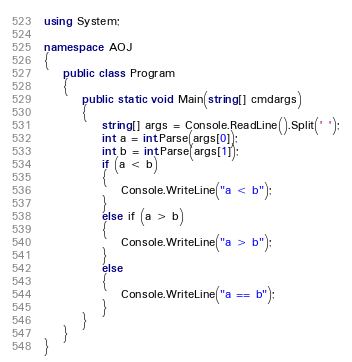Convert code to text. <code><loc_0><loc_0><loc_500><loc_500><_C#_>using System;

namespace AOJ
{
    public class Program
    {
        public static void Main(string[] cmdargs)
        {
            string[] args = Console.ReadLine().Split(' ');
            int a = int.Parse(args[0]);
            int b = int.Parse(args[1]);
            if (a < b)
            {
                Console.WriteLine("a < b");
            }
            else if (a > b)
            {
                Console.WriteLine("a > b");
            }
            else
            {
                Console.WriteLine("a == b");
            }
        }
    }
}</code> 